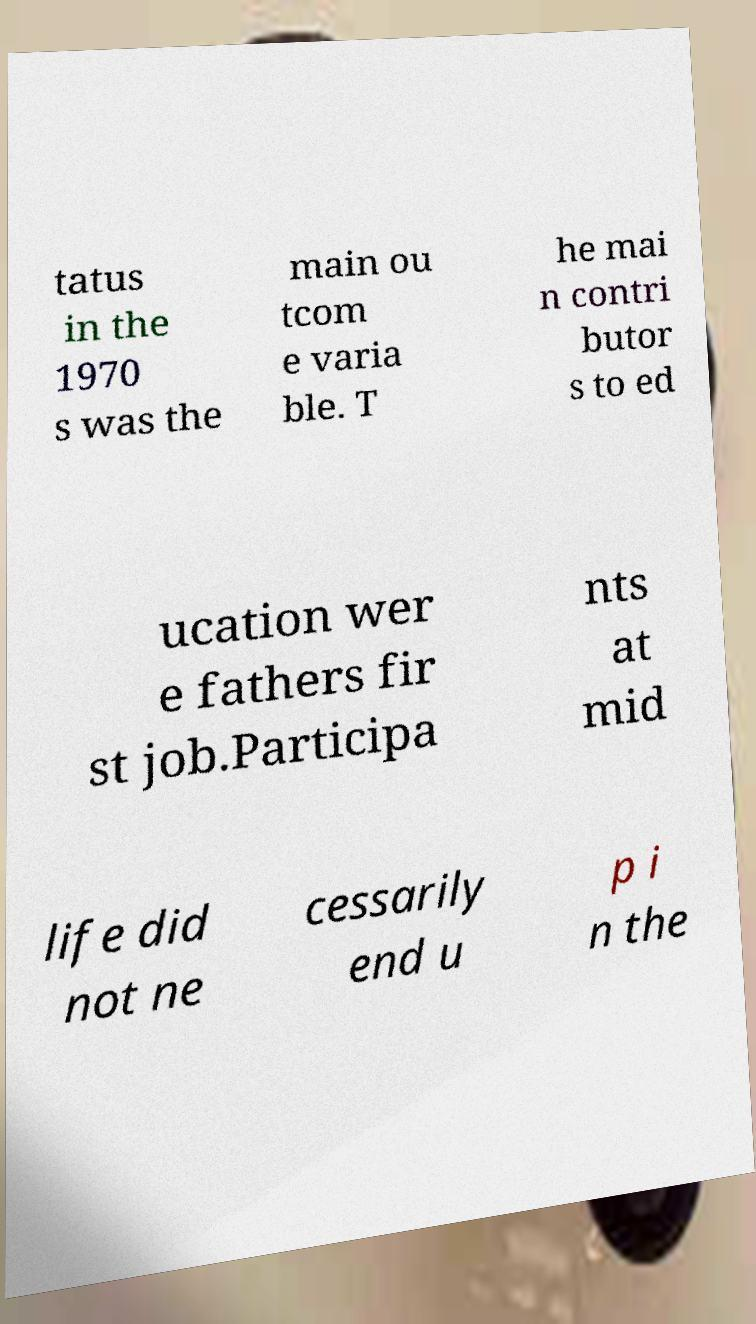For documentation purposes, I need the text within this image transcribed. Could you provide that? tatus in the 1970 s was the main ou tcom e varia ble. T he mai n contri butor s to ed ucation wer e fathers fir st job.Participa nts at mid life did not ne cessarily end u p i n the 